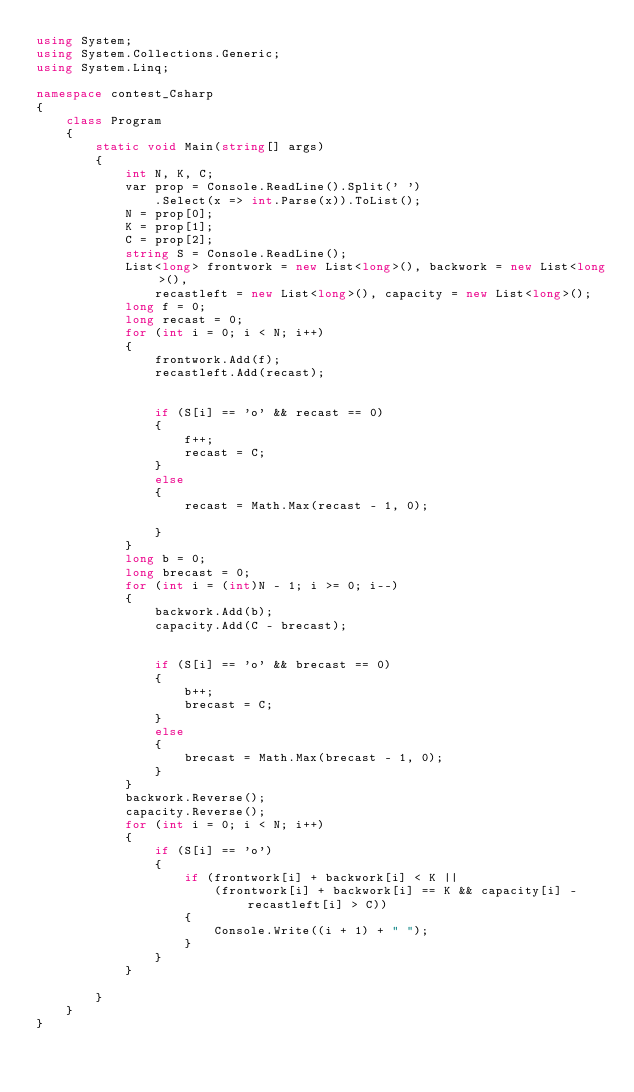<code> <loc_0><loc_0><loc_500><loc_500><_C#_>using System;
using System.Collections.Generic;
using System.Linq;

namespace contest_Csharp
{
    class Program
    {
        static void Main(string[] args)
        {
            int N, K, C;
            var prop = Console.ReadLine().Split(' ')
                .Select(x => int.Parse(x)).ToList();
            N = prop[0];
            K = prop[1];
            C = prop[2];
            string S = Console.ReadLine();
            List<long> frontwork = new List<long>(), backwork = new List<long>(),
                recastleft = new List<long>(), capacity = new List<long>();
            long f = 0;
            long recast = 0;
            for (int i = 0; i < N; i++)
            {
                frontwork.Add(f);
                recastleft.Add(recast);


                if (S[i] == 'o' && recast == 0)
                {
                    f++;
                    recast = C;
                }
                else
                {
                    recast = Math.Max(recast - 1, 0);

                }
            }
            long b = 0;
            long brecast = 0;
            for (int i = (int)N - 1; i >= 0; i--)
            {
                backwork.Add(b);
                capacity.Add(C - brecast);


                if (S[i] == 'o' && brecast == 0)
                {
                    b++;
                    brecast = C;
                }
                else
                {
                    brecast = Math.Max(brecast - 1, 0);
                }
            }
            backwork.Reverse();
            capacity.Reverse();
            for (int i = 0; i < N; i++)
            {
                if (S[i] == 'o')
                {
                    if (frontwork[i] + backwork[i] < K ||
                        (frontwork[i] + backwork[i] == K && capacity[i] - recastleft[i] > C))
                    {
                        Console.Write((i + 1) + " ");
                    }
                }
            }

        }
    }
}
</code> 